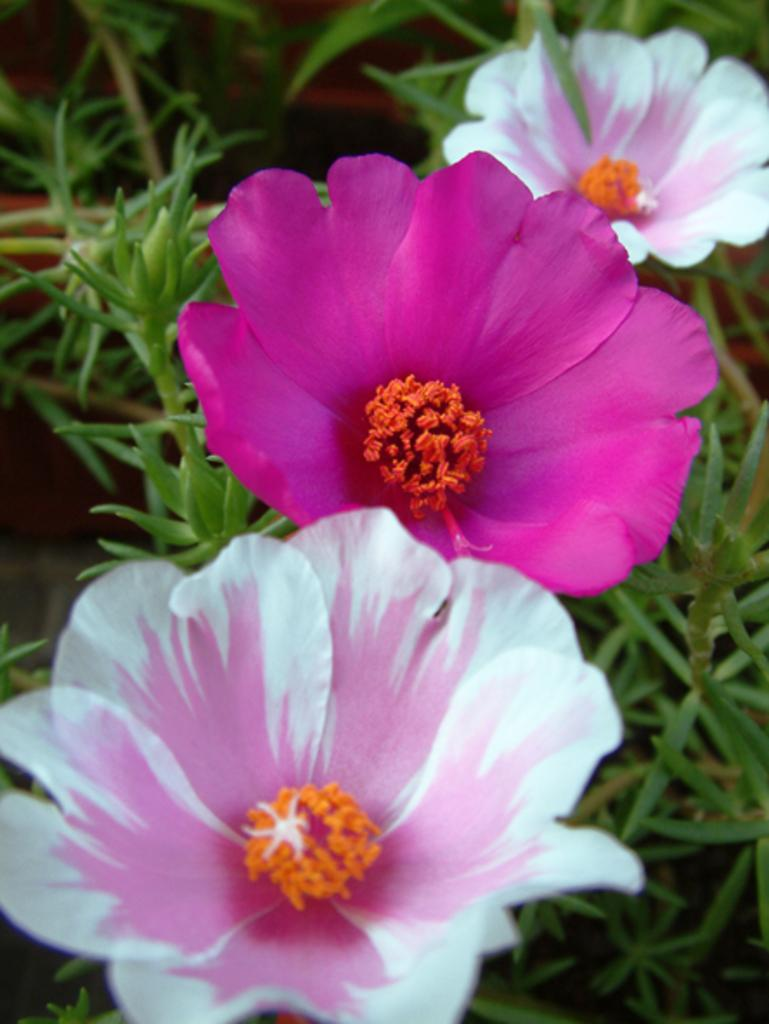What colors are the flowers in the image? The flowers in the image are pink and white. What other colors can be seen in the image besides the flowers? There are orange color buds and green color leaves in the image. How would you describe the leaves in the image? The leaves in the image are green. What is the quality of the background in the image? The background of the image is slightly blurry. What type of mind control is being used on the flowers in the image? There is no indication of mind control or any other form of manipulation in the image; it simply depicts flowers, buds, and leaves. 